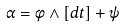Convert formula to latex. <formula><loc_0><loc_0><loc_500><loc_500>\alpha = \phi \wedge [ d t ] + \psi</formula> 